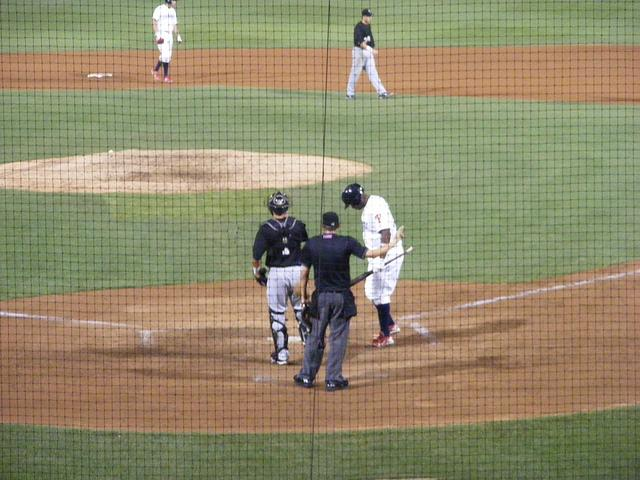Who is wearing the most gear? Please explain your reasoning. catcher. It's to protect them from being hurt by the ball. 